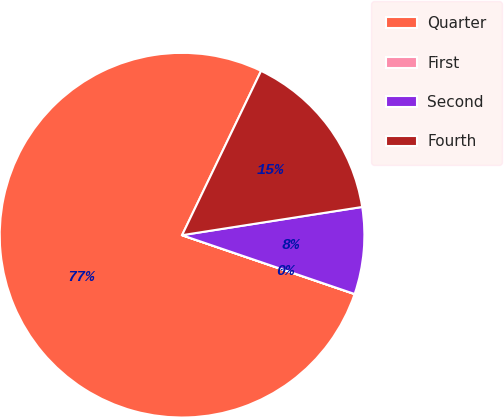Convert chart to OTSL. <chart><loc_0><loc_0><loc_500><loc_500><pie_chart><fcel>Quarter<fcel>First<fcel>Second<fcel>Fourth<nl><fcel>76.89%<fcel>0.01%<fcel>7.7%<fcel>15.39%<nl></chart> 